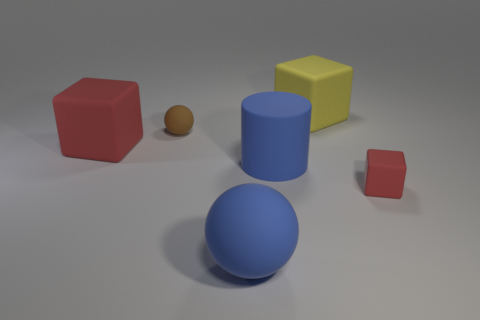Add 3 brown matte things. How many objects exist? 9 Subtract all green cubes. Subtract all blue balls. How many cubes are left? 3 Subtract all cylinders. How many objects are left? 5 Add 1 tiny green metal cubes. How many tiny green metal cubes exist? 1 Subtract 0 brown cubes. How many objects are left? 6 Subtract all blue matte balls. Subtract all big blue objects. How many objects are left? 3 Add 6 red blocks. How many red blocks are left? 8 